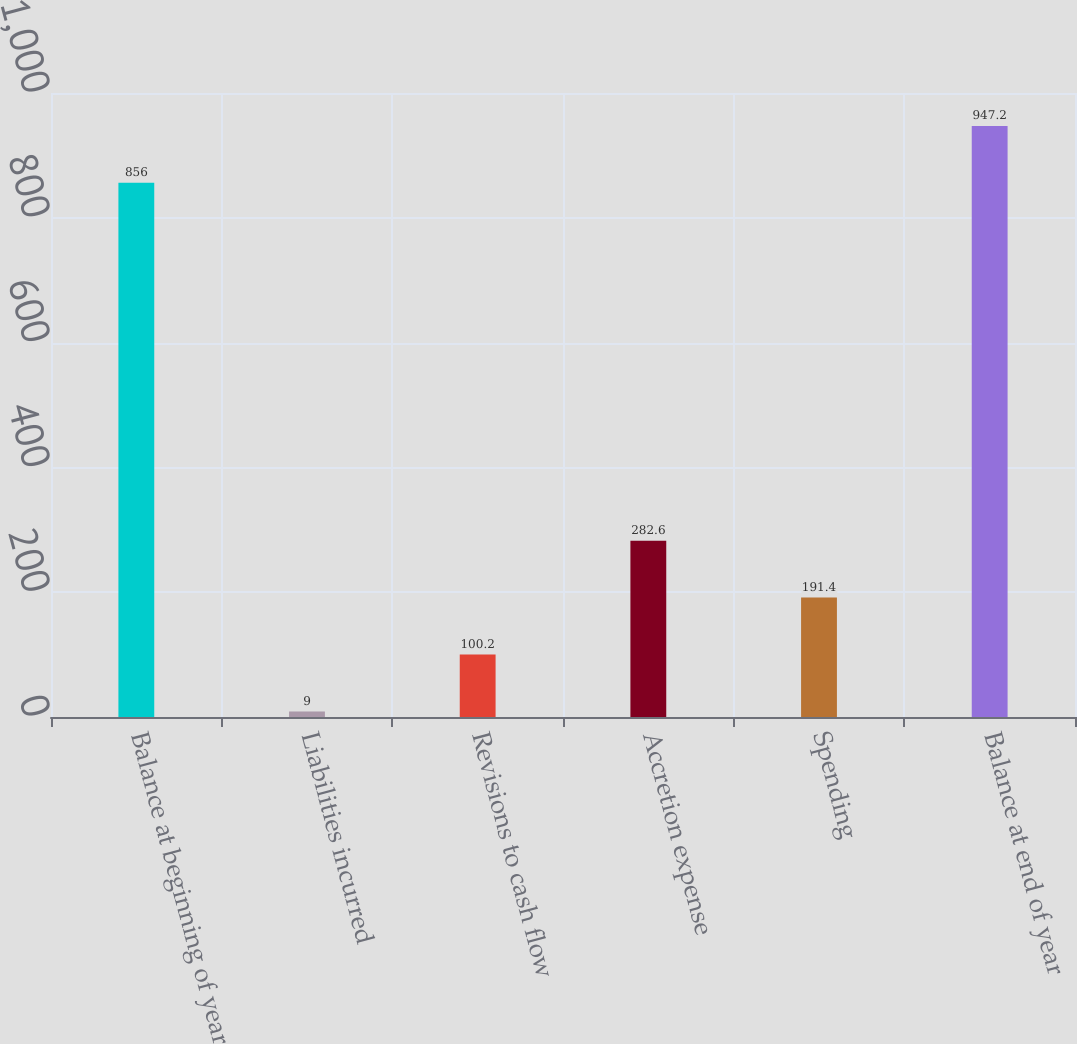Convert chart to OTSL. <chart><loc_0><loc_0><loc_500><loc_500><bar_chart><fcel>Balance at beginning of year<fcel>Liabilities incurred<fcel>Revisions to cash flow<fcel>Accretion expense<fcel>Spending<fcel>Balance at end of year<nl><fcel>856<fcel>9<fcel>100.2<fcel>282.6<fcel>191.4<fcel>947.2<nl></chart> 